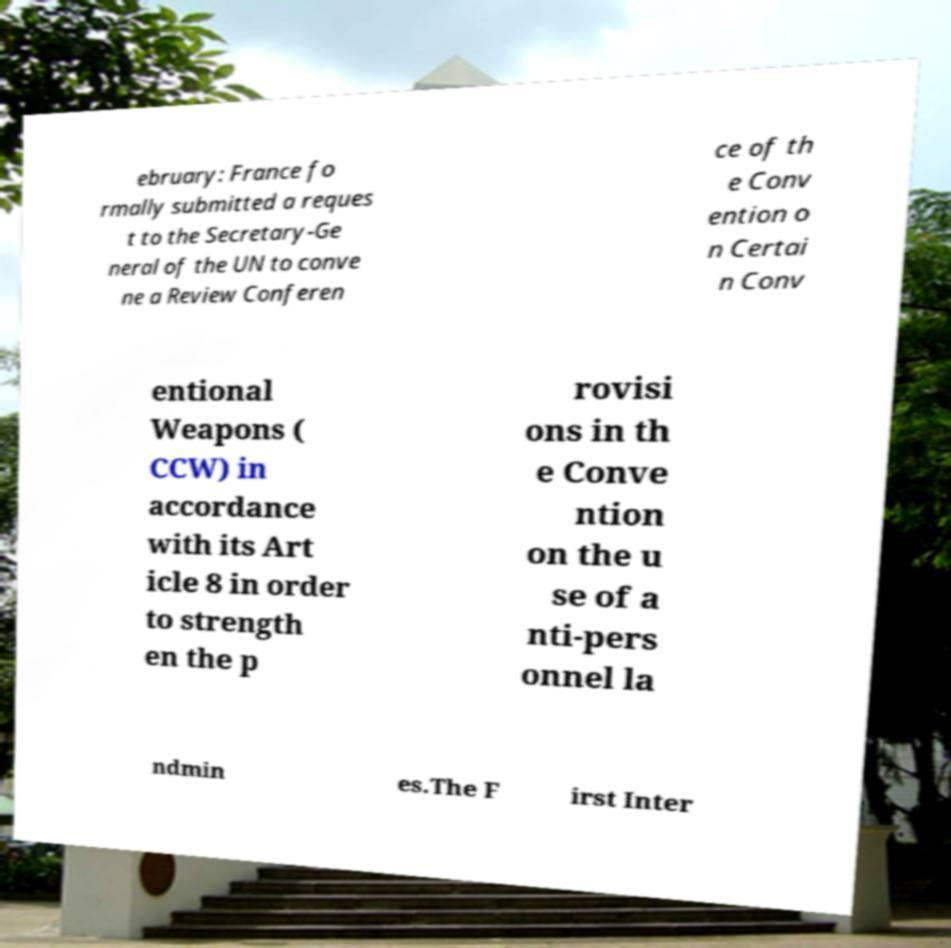Please identify and transcribe the text found in this image. ebruary: France fo rmally submitted a reques t to the Secretary-Ge neral of the UN to conve ne a Review Conferen ce of th e Conv ention o n Certai n Conv entional Weapons ( CCW) in accordance with its Art icle 8 in order to strength en the p rovisi ons in th e Conve ntion on the u se of a nti-pers onnel la ndmin es.The F irst Inter 